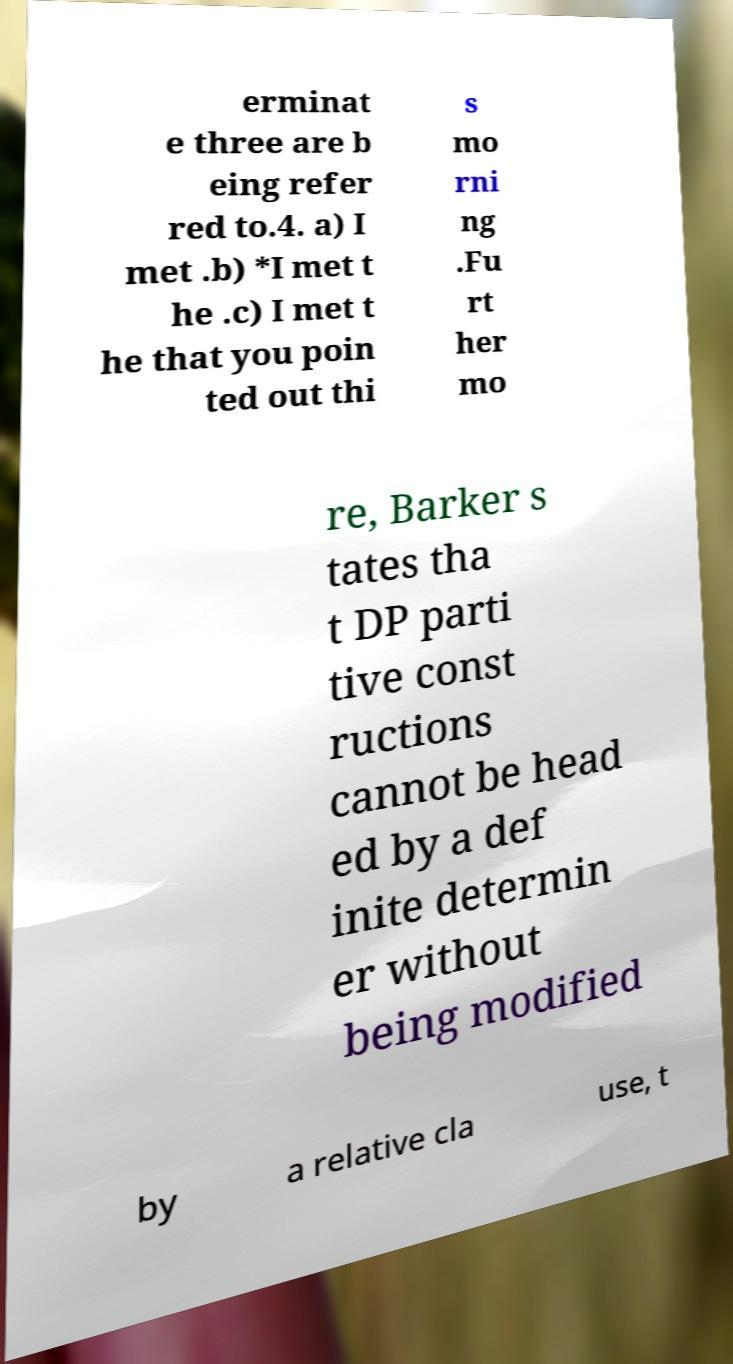Please identify and transcribe the text found in this image. erminat e three are b eing refer red to.4. a) I met .b) *I met t he .c) I met t he that you poin ted out thi s mo rni ng .Fu rt her mo re, Barker s tates tha t DP parti tive const ructions cannot be head ed by a def inite determin er without being modified by a relative cla use, t 